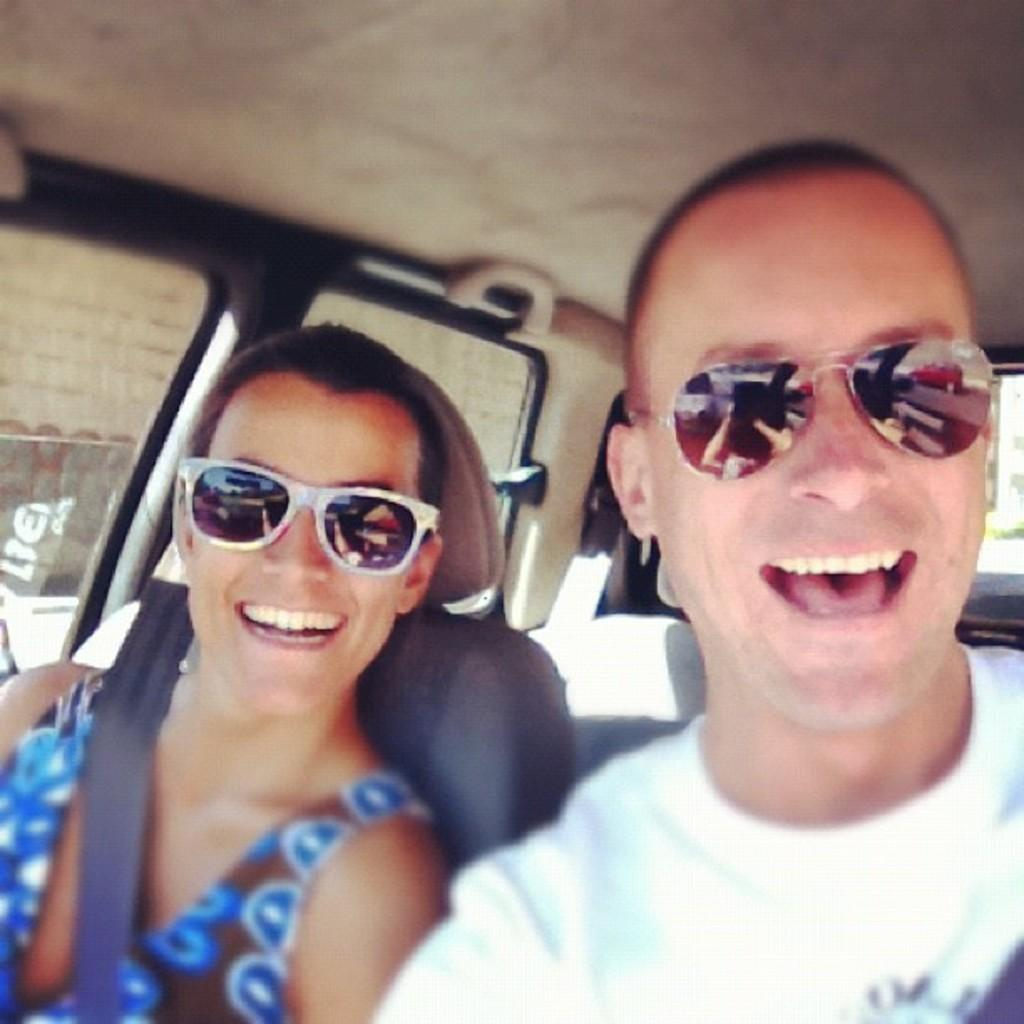How many people are present in the image? There are two people in the image, a man and a woman. What are the man and woman doing in the image? The man and woman are seated in a vehicle. What are the man and woman wearing in the image? The man and woman are both wearing sunglasses. What can be seen through the vehicle's glass in the image? There is a wall visible through the vehicle's glass. What language is the man speaking to the servant in the image? There is no servant present in the image, and the man is not speaking to anyone. 